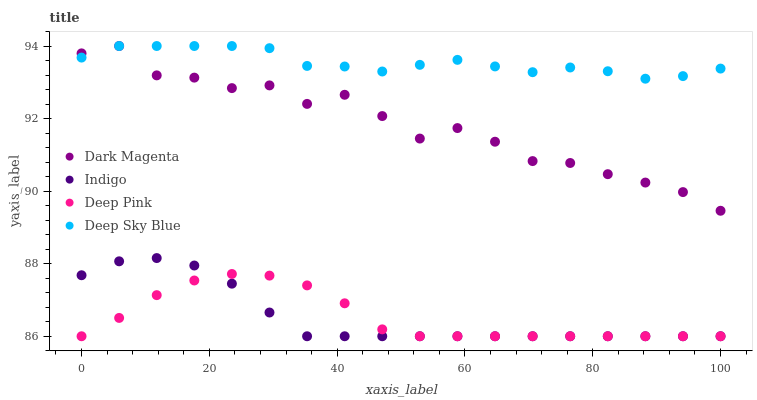Does Deep Pink have the minimum area under the curve?
Answer yes or no. Yes. Does Deep Sky Blue have the maximum area under the curve?
Answer yes or no. Yes. Does Indigo have the minimum area under the curve?
Answer yes or no. No. Does Indigo have the maximum area under the curve?
Answer yes or no. No. Is Indigo the smoothest?
Answer yes or no. Yes. Is Dark Magenta the roughest?
Answer yes or no. Yes. Is Dark Magenta the smoothest?
Answer yes or no. No. Is Indigo the roughest?
Answer yes or no. No. Does Deep Pink have the lowest value?
Answer yes or no. Yes. Does Dark Magenta have the lowest value?
Answer yes or no. No. Does Deep Sky Blue have the highest value?
Answer yes or no. Yes. Does Indigo have the highest value?
Answer yes or no. No. Is Deep Pink less than Deep Sky Blue?
Answer yes or no. Yes. Is Deep Sky Blue greater than Indigo?
Answer yes or no. Yes. Does Deep Sky Blue intersect Dark Magenta?
Answer yes or no. Yes. Is Deep Sky Blue less than Dark Magenta?
Answer yes or no. No. Is Deep Sky Blue greater than Dark Magenta?
Answer yes or no. No. Does Deep Pink intersect Deep Sky Blue?
Answer yes or no. No. 